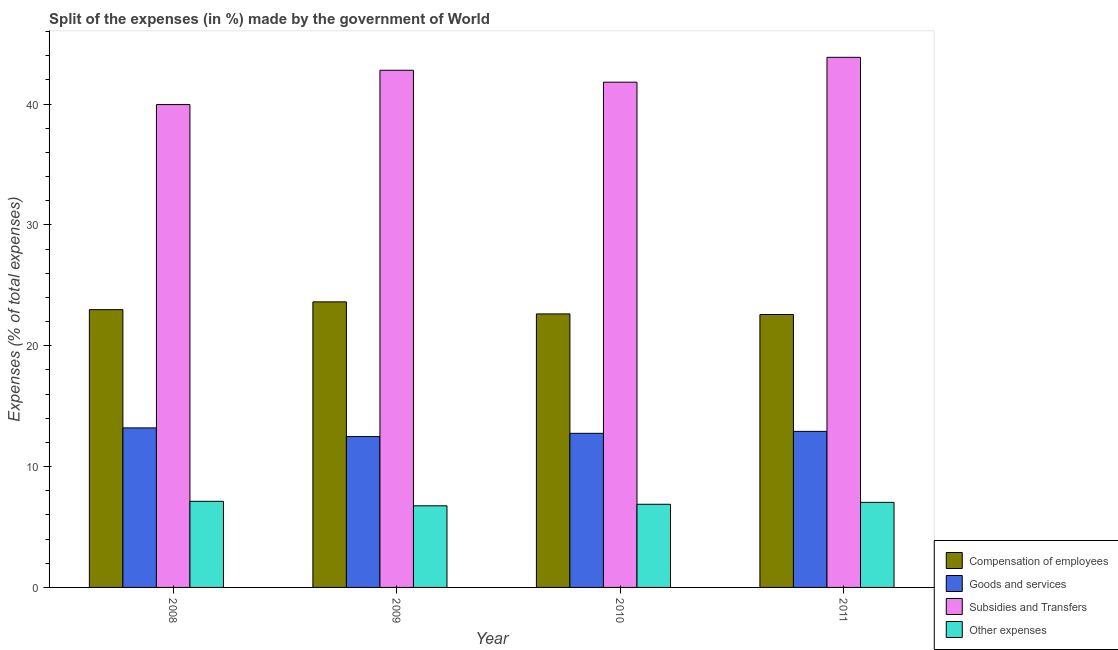How many different coloured bars are there?
Give a very brief answer. 4. Are the number of bars on each tick of the X-axis equal?
Ensure brevity in your answer.  Yes. How many bars are there on the 2nd tick from the right?
Offer a terse response. 4. In how many cases, is the number of bars for a given year not equal to the number of legend labels?
Ensure brevity in your answer.  0. What is the percentage of amount spent on compensation of employees in 2010?
Offer a very short reply. 22.63. Across all years, what is the maximum percentage of amount spent on other expenses?
Provide a succinct answer. 7.13. Across all years, what is the minimum percentage of amount spent on compensation of employees?
Ensure brevity in your answer.  22.58. What is the total percentage of amount spent on compensation of employees in the graph?
Offer a terse response. 91.83. What is the difference between the percentage of amount spent on goods and services in 2010 and that in 2011?
Ensure brevity in your answer.  -0.16. What is the difference between the percentage of amount spent on subsidies in 2008 and the percentage of amount spent on goods and services in 2010?
Ensure brevity in your answer.  -1.85. What is the average percentage of amount spent on compensation of employees per year?
Give a very brief answer. 22.96. In how many years, is the percentage of amount spent on subsidies greater than 22 %?
Your response must be concise. 4. What is the ratio of the percentage of amount spent on other expenses in 2009 to that in 2011?
Provide a short and direct response. 0.96. Is the percentage of amount spent on goods and services in 2008 less than that in 2010?
Your response must be concise. No. Is the difference between the percentage of amount spent on other expenses in 2009 and 2011 greater than the difference between the percentage of amount spent on subsidies in 2009 and 2011?
Offer a very short reply. No. What is the difference between the highest and the second highest percentage of amount spent on other expenses?
Provide a succinct answer. 0.09. What is the difference between the highest and the lowest percentage of amount spent on other expenses?
Provide a short and direct response. 0.37. Is the sum of the percentage of amount spent on subsidies in 2009 and 2011 greater than the maximum percentage of amount spent on goods and services across all years?
Provide a succinct answer. Yes. Is it the case that in every year, the sum of the percentage of amount spent on goods and services and percentage of amount spent on subsidies is greater than the sum of percentage of amount spent on other expenses and percentage of amount spent on compensation of employees?
Your response must be concise. Yes. What does the 2nd bar from the left in 2008 represents?
Provide a short and direct response. Goods and services. What does the 2nd bar from the right in 2008 represents?
Provide a succinct answer. Subsidies and Transfers. Are all the bars in the graph horizontal?
Offer a very short reply. No. How many years are there in the graph?
Your response must be concise. 4. Are the values on the major ticks of Y-axis written in scientific E-notation?
Give a very brief answer. No. Does the graph contain any zero values?
Provide a succinct answer. No. Does the graph contain grids?
Give a very brief answer. No. How many legend labels are there?
Give a very brief answer. 4. How are the legend labels stacked?
Keep it short and to the point. Vertical. What is the title of the graph?
Give a very brief answer. Split of the expenses (in %) made by the government of World. Does "Tertiary education" appear as one of the legend labels in the graph?
Your answer should be very brief. No. What is the label or title of the Y-axis?
Make the answer very short. Expenses (% of total expenses). What is the Expenses (% of total expenses) of Compensation of employees in 2008?
Offer a terse response. 22.98. What is the Expenses (% of total expenses) in Goods and services in 2008?
Your response must be concise. 13.2. What is the Expenses (% of total expenses) in Subsidies and Transfers in 2008?
Your answer should be very brief. 39.95. What is the Expenses (% of total expenses) in Other expenses in 2008?
Give a very brief answer. 7.13. What is the Expenses (% of total expenses) in Compensation of employees in 2009?
Make the answer very short. 23.63. What is the Expenses (% of total expenses) of Goods and services in 2009?
Offer a very short reply. 12.48. What is the Expenses (% of total expenses) of Subsidies and Transfers in 2009?
Make the answer very short. 42.79. What is the Expenses (% of total expenses) in Other expenses in 2009?
Keep it short and to the point. 6.75. What is the Expenses (% of total expenses) in Compensation of employees in 2010?
Offer a terse response. 22.63. What is the Expenses (% of total expenses) of Goods and services in 2010?
Provide a short and direct response. 12.75. What is the Expenses (% of total expenses) in Subsidies and Transfers in 2010?
Offer a very short reply. 41.81. What is the Expenses (% of total expenses) in Other expenses in 2010?
Your answer should be compact. 6.88. What is the Expenses (% of total expenses) of Compensation of employees in 2011?
Your answer should be very brief. 22.58. What is the Expenses (% of total expenses) of Goods and services in 2011?
Your answer should be compact. 12.91. What is the Expenses (% of total expenses) of Subsidies and Transfers in 2011?
Your response must be concise. 43.86. What is the Expenses (% of total expenses) in Other expenses in 2011?
Provide a short and direct response. 7.04. Across all years, what is the maximum Expenses (% of total expenses) in Compensation of employees?
Keep it short and to the point. 23.63. Across all years, what is the maximum Expenses (% of total expenses) in Goods and services?
Make the answer very short. 13.2. Across all years, what is the maximum Expenses (% of total expenses) in Subsidies and Transfers?
Offer a very short reply. 43.86. Across all years, what is the maximum Expenses (% of total expenses) in Other expenses?
Make the answer very short. 7.13. Across all years, what is the minimum Expenses (% of total expenses) of Compensation of employees?
Keep it short and to the point. 22.58. Across all years, what is the minimum Expenses (% of total expenses) in Goods and services?
Your answer should be compact. 12.48. Across all years, what is the minimum Expenses (% of total expenses) of Subsidies and Transfers?
Offer a terse response. 39.95. Across all years, what is the minimum Expenses (% of total expenses) in Other expenses?
Offer a terse response. 6.75. What is the total Expenses (% of total expenses) in Compensation of employees in the graph?
Make the answer very short. 91.83. What is the total Expenses (% of total expenses) in Goods and services in the graph?
Your answer should be very brief. 51.35. What is the total Expenses (% of total expenses) of Subsidies and Transfers in the graph?
Your answer should be compact. 168.41. What is the total Expenses (% of total expenses) in Other expenses in the graph?
Your answer should be very brief. 27.8. What is the difference between the Expenses (% of total expenses) in Compensation of employees in 2008 and that in 2009?
Offer a terse response. -0.64. What is the difference between the Expenses (% of total expenses) in Goods and services in 2008 and that in 2009?
Make the answer very short. 0.72. What is the difference between the Expenses (% of total expenses) of Subsidies and Transfers in 2008 and that in 2009?
Give a very brief answer. -2.84. What is the difference between the Expenses (% of total expenses) in Other expenses in 2008 and that in 2009?
Provide a short and direct response. 0.37. What is the difference between the Expenses (% of total expenses) of Compensation of employees in 2008 and that in 2010?
Make the answer very short. 0.35. What is the difference between the Expenses (% of total expenses) of Goods and services in 2008 and that in 2010?
Offer a very short reply. 0.45. What is the difference between the Expenses (% of total expenses) in Subsidies and Transfers in 2008 and that in 2010?
Your response must be concise. -1.85. What is the difference between the Expenses (% of total expenses) in Other expenses in 2008 and that in 2010?
Offer a terse response. 0.24. What is the difference between the Expenses (% of total expenses) of Compensation of employees in 2008 and that in 2011?
Give a very brief answer. 0.4. What is the difference between the Expenses (% of total expenses) of Goods and services in 2008 and that in 2011?
Your response must be concise. 0.29. What is the difference between the Expenses (% of total expenses) in Subsidies and Transfers in 2008 and that in 2011?
Ensure brevity in your answer.  -3.91. What is the difference between the Expenses (% of total expenses) of Other expenses in 2008 and that in 2011?
Ensure brevity in your answer.  0.09. What is the difference between the Expenses (% of total expenses) in Compensation of employees in 2009 and that in 2010?
Your answer should be very brief. 1. What is the difference between the Expenses (% of total expenses) of Goods and services in 2009 and that in 2010?
Offer a terse response. -0.27. What is the difference between the Expenses (% of total expenses) of Subsidies and Transfers in 2009 and that in 2010?
Ensure brevity in your answer.  0.99. What is the difference between the Expenses (% of total expenses) in Other expenses in 2009 and that in 2010?
Make the answer very short. -0.13. What is the difference between the Expenses (% of total expenses) of Compensation of employees in 2009 and that in 2011?
Keep it short and to the point. 1.04. What is the difference between the Expenses (% of total expenses) in Goods and services in 2009 and that in 2011?
Provide a short and direct response. -0.43. What is the difference between the Expenses (% of total expenses) of Subsidies and Transfers in 2009 and that in 2011?
Your answer should be compact. -1.07. What is the difference between the Expenses (% of total expenses) in Other expenses in 2009 and that in 2011?
Your answer should be compact. -0.28. What is the difference between the Expenses (% of total expenses) of Compensation of employees in 2010 and that in 2011?
Make the answer very short. 0.05. What is the difference between the Expenses (% of total expenses) of Goods and services in 2010 and that in 2011?
Provide a succinct answer. -0.16. What is the difference between the Expenses (% of total expenses) in Subsidies and Transfers in 2010 and that in 2011?
Offer a terse response. -2.06. What is the difference between the Expenses (% of total expenses) in Other expenses in 2010 and that in 2011?
Make the answer very short. -0.16. What is the difference between the Expenses (% of total expenses) in Compensation of employees in 2008 and the Expenses (% of total expenses) in Goods and services in 2009?
Your answer should be compact. 10.5. What is the difference between the Expenses (% of total expenses) in Compensation of employees in 2008 and the Expenses (% of total expenses) in Subsidies and Transfers in 2009?
Keep it short and to the point. -19.81. What is the difference between the Expenses (% of total expenses) of Compensation of employees in 2008 and the Expenses (% of total expenses) of Other expenses in 2009?
Offer a terse response. 16.23. What is the difference between the Expenses (% of total expenses) in Goods and services in 2008 and the Expenses (% of total expenses) in Subsidies and Transfers in 2009?
Give a very brief answer. -29.59. What is the difference between the Expenses (% of total expenses) in Goods and services in 2008 and the Expenses (% of total expenses) in Other expenses in 2009?
Your answer should be very brief. 6.45. What is the difference between the Expenses (% of total expenses) of Subsidies and Transfers in 2008 and the Expenses (% of total expenses) of Other expenses in 2009?
Offer a terse response. 33.2. What is the difference between the Expenses (% of total expenses) of Compensation of employees in 2008 and the Expenses (% of total expenses) of Goods and services in 2010?
Your response must be concise. 10.23. What is the difference between the Expenses (% of total expenses) in Compensation of employees in 2008 and the Expenses (% of total expenses) in Subsidies and Transfers in 2010?
Give a very brief answer. -18.82. What is the difference between the Expenses (% of total expenses) of Compensation of employees in 2008 and the Expenses (% of total expenses) of Other expenses in 2010?
Give a very brief answer. 16.1. What is the difference between the Expenses (% of total expenses) of Goods and services in 2008 and the Expenses (% of total expenses) of Subsidies and Transfers in 2010?
Make the answer very short. -28.61. What is the difference between the Expenses (% of total expenses) in Goods and services in 2008 and the Expenses (% of total expenses) in Other expenses in 2010?
Keep it short and to the point. 6.32. What is the difference between the Expenses (% of total expenses) of Subsidies and Transfers in 2008 and the Expenses (% of total expenses) of Other expenses in 2010?
Your answer should be very brief. 33.07. What is the difference between the Expenses (% of total expenses) in Compensation of employees in 2008 and the Expenses (% of total expenses) in Goods and services in 2011?
Make the answer very short. 10.07. What is the difference between the Expenses (% of total expenses) of Compensation of employees in 2008 and the Expenses (% of total expenses) of Subsidies and Transfers in 2011?
Give a very brief answer. -20.88. What is the difference between the Expenses (% of total expenses) of Compensation of employees in 2008 and the Expenses (% of total expenses) of Other expenses in 2011?
Keep it short and to the point. 15.95. What is the difference between the Expenses (% of total expenses) in Goods and services in 2008 and the Expenses (% of total expenses) in Subsidies and Transfers in 2011?
Provide a short and direct response. -30.66. What is the difference between the Expenses (% of total expenses) of Goods and services in 2008 and the Expenses (% of total expenses) of Other expenses in 2011?
Offer a very short reply. 6.16. What is the difference between the Expenses (% of total expenses) in Subsidies and Transfers in 2008 and the Expenses (% of total expenses) in Other expenses in 2011?
Provide a short and direct response. 32.92. What is the difference between the Expenses (% of total expenses) in Compensation of employees in 2009 and the Expenses (% of total expenses) in Goods and services in 2010?
Keep it short and to the point. 10.88. What is the difference between the Expenses (% of total expenses) of Compensation of employees in 2009 and the Expenses (% of total expenses) of Subsidies and Transfers in 2010?
Provide a succinct answer. -18.18. What is the difference between the Expenses (% of total expenses) of Compensation of employees in 2009 and the Expenses (% of total expenses) of Other expenses in 2010?
Offer a very short reply. 16.75. What is the difference between the Expenses (% of total expenses) in Goods and services in 2009 and the Expenses (% of total expenses) in Subsidies and Transfers in 2010?
Offer a terse response. -29.32. What is the difference between the Expenses (% of total expenses) in Goods and services in 2009 and the Expenses (% of total expenses) in Other expenses in 2010?
Provide a short and direct response. 5.6. What is the difference between the Expenses (% of total expenses) of Subsidies and Transfers in 2009 and the Expenses (% of total expenses) of Other expenses in 2010?
Provide a succinct answer. 35.91. What is the difference between the Expenses (% of total expenses) of Compensation of employees in 2009 and the Expenses (% of total expenses) of Goods and services in 2011?
Ensure brevity in your answer.  10.72. What is the difference between the Expenses (% of total expenses) in Compensation of employees in 2009 and the Expenses (% of total expenses) in Subsidies and Transfers in 2011?
Provide a short and direct response. -20.23. What is the difference between the Expenses (% of total expenses) in Compensation of employees in 2009 and the Expenses (% of total expenses) in Other expenses in 2011?
Give a very brief answer. 16.59. What is the difference between the Expenses (% of total expenses) in Goods and services in 2009 and the Expenses (% of total expenses) in Subsidies and Transfers in 2011?
Give a very brief answer. -31.38. What is the difference between the Expenses (% of total expenses) in Goods and services in 2009 and the Expenses (% of total expenses) in Other expenses in 2011?
Ensure brevity in your answer.  5.44. What is the difference between the Expenses (% of total expenses) in Subsidies and Transfers in 2009 and the Expenses (% of total expenses) in Other expenses in 2011?
Make the answer very short. 35.75. What is the difference between the Expenses (% of total expenses) in Compensation of employees in 2010 and the Expenses (% of total expenses) in Goods and services in 2011?
Keep it short and to the point. 9.72. What is the difference between the Expenses (% of total expenses) of Compensation of employees in 2010 and the Expenses (% of total expenses) of Subsidies and Transfers in 2011?
Offer a terse response. -21.23. What is the difference between the Expenses (% of total expenses) in Compensation of employees in 2010 and the Expenses (% of total expenses) in Other expenses in 2011?
Provide a succinct answer. 15.59. What is the difference between the Expenses (% of total expenses) in Goods and services in 2010 and the Expenses (% of total expenses) in Subsidies and Transfers in 2011?
Your answer should be compact. -31.11. What is the difference between the Expenses (% of total expenses) in Goods and services in 2010 and the Expenses (% of total expenses) in Other expenses in 2011?
Your answer should be very brief. 5.71. What is the difference between the Expenses (% of total expenses) of Subsidies and Transfers in 2010 and the Expenses (% of total expenses) of Other expenses in 2011?
Give a very brief answer. 34.77. What is the average Expenses (% of total expenses) in Compensation of employees per year?
Make the answer very short. 22.96. What is the average Expenses (% of total expenses) of Goods and services per year?
Give a very brief answer. 12.84. What is the average Expenses (% of total expenses) in Subsidies and Transfers per year?
Your answer should be very brief. 42.1. What is the average Expenses (% of total expenses) of Other expenses per year?
Keep it short and to the point. 6.95. In the year 2008, what is the difference between the Expenses (% of total expenses) of Compensation of employees and Expenses (% of total expenses) of Goods and services?
Your answer should be very brief. 9.78. In the year 2008, what is the difference between the Expenses (% of total expenses) of Compensation of employees and Expenses (% of total expenses) of Subsidies and Transfers?
Your response must be concise. -16.97. In the year 2008, what is the difference between the Expenses (% of total expenses) in Compensation of employees and Expenses (% of total expenses) in Other expenses?
Your answer should be compact. 15.86. In the year 2008, what is the difference between the Expenses (% of total expenses) of Goods and services and Expenses (% of total expenses) of Subsidies and Transfers?
Offer a very short reply. -26.75. In the year 2008, what is the difference between the Expenses (% of total expenses) in Goods and services and Expenses (% of total expenses) in Other expenses?
Provide a succinct answer. 6.07. In the year 2008, what is the difference between the Expenses (% of total expenses) in Subsidies and Transfers and Expenses (% of total expenses) in Other expenses?
Keep it short and to the point. 32.83. In the year 2009, what is the difference between the Expenses (% of total expenses) of Compensation of employees and Expenses (% of total expenses) of Goods and services?
Make the answer very short. 11.15. In the year 2009, what is the difference between the Expenses (% of total expenses) of Compensation of employees and Expenses (% of total expenses) of Subsidies and Transfers?
Provide a short and direct response. -19.16. In the year 2009, what is the difference between the Expenses (% of total expenses) in Compensation of employees and Expenses (% of total expenses) in Other expenses?
Offer a terse response. 16.87. In the year 2009, what is the difference between the Expenses (% of total expenses) of Goods and services and Expenses (% of total expenses) of Subsidies and Transfers?
Give a very brief answer. -30.31. In the year 2009, what is the difference between the Expenses (% of total expenses) of Goods and services and Expenses (% of total expenses) of Other expenses?
Your response must be concise. 5.73. In the year 2009, what is the difference between the Expenses (% of total expenses) in Subsidies and Transfers and Expenses (% of total expenses) in Other expenses?
Offer a terse response. 36.04. In the year 2010, what is the difference between the Expenses (% of total expenses) in Compensation of employees and Expenses (% of total expenses) in Goods and services?
Provide a short and direct response. 9.88. In the year 2010, what is the difference between the Expenses (% of total expenses) in Compensation of employees and Expenses (% of total expenses) in Subsidies and Transfers?
Make the answer very short. -19.18. In the year 2010, what is the difference between the Expenses (% of total expenses) of Compensation of employees and Expenses (% of total expenses) of Other expenses?
Make the answer very short. 15.75. In the year 2010, what is the difference between the Expenses (% of total expenses) in Goods and services and Expenses (% of total expenses) in Subsidies and Transfers?
Ensure brevity in your answer.  -29.05. In the year 2010, what is the difference between the Expenses (% of total expenses) of Goods and services and Expenses (% of total expenses) of Other expenses?
Make the answer very short. 5.87. In the year 2010, what is the difference between the Expenses (% of total expenses) of Subsidies and Transfers and Expenses (% of total expenses) of Other expenses?
Provide a short and direct response. 34.93. In the year 2011, what is the difference between the Expenses (% of total expenses) of Compensation of employees and Expenses (% of total expenses) of Goods and services?
Ensure brevity in your answer.  9.67. In the year 2011, what is the difference between the Expenses (% of total expenses) in Compensation of employees and Expenses (% of total expenses) in Subsidies and Transfers?
Offer a terse response. -21.28. In the year 2011, what is the difference between the Expenses (% of total expenses) in Compensation of employees and Expenses (% of total expenses) in Other expenses?
Provide a succinct answer. 15.55. In the year 2011, what is the difference between the Expenses (% of total expenses) in Goods and services and Expenses (% of total expenses) in Subsidies and Transfers?
Your answer should be very brief. -30.95. In the year 2011, what is the difference between the Expenses (% of total expenses) of Goods and services and Expenses (% of total expenses) of Other expenses?
Give a very brief answer. 5.87. In the year 2011, what is the difference between the Expenses (% of total expenses) in Subsidies and Transfers and Expenses (% of total expenses) in Other expenses?
Provide a short and direct response. 36.82. What is the ratio of the Expenses (% of total expenses) of Compensation of employees in 2008 to that in 2009?
Offer a terse response. 0.97. What is the ratio of the Expenses (% of total expenses) of Goods and services in 2008 to that in 2009?
Your response must be concise. 1.06. What is the ratio of the Expenses (% of total expenses) of Subsidies and Transfers in 2008 to that in 2009?
Give a very brief answer. 0.93. What is the ratio of the Expenses (% of total expenses) of Other expenses in 2008 to that in 2009?
Your answer should be very brief. 1.05. What is the ratio of the Expenses (% of total expenses) in Compensation of employees in 2008 to that in 2010?
Provide a succinct answer. 1.02. What is the ratio of the Expenses (% of total expenses) in Goods and services in 2008 to that in 2010?
Keep it short and to the point. 1.04. What is the ratio of the Expenses (% of total expenses) of Subsidies and Transfers in 2008 to that in 2010?
Your answer should be very brief. 0.96. What is the ratio of the Expenses (% of total expenses) in Other expenses in 2008 to that in 2010?
Your answer should be very brief. 1.04. What is the ratio of the Expenses (% of total expenses) in Compensation of employees in 2008 to that in 2011?
Ensure brevity in your answer.  1.02. What is the ratio of the Expenses (% of total expenses) of Goods and services in 2008 to that in 2011?
Your response must be concise. 1.02. What is the ratio of the Expenses (% of total expenses) of Subsidies and Transfers in 2008 to that in 2011?
Keep it short and to the point. 0.91. What is the ratio of the Expenses (% of total expenses) of Other expenses in 2008 to that in 2011?
Offer a very short reply. 1.01. What is the ratio of the Expenses (% of total expenses) of Compensation of employees in 2009 to that in 2010?
Make the answer very short. 1.04. What is the ratio of the Expenses (% of total expenses) in Goods and services in 2009 to that in 2010?
Provide a short and direct response. 0.98. What is the ratio of the Expenses (% of total expenses) in Subsidies and Transfers in 2009 to that in 2010?
Offer a very short reply. 1.02. What is the ratio of the Expenses (% of total expenses) of Other expenses in 2009 to that in 2010?
Keep it short and to the point. 0.98. What is the ratio of the Expenses (% of total expenses) in Compensation of employees in 2009 to that in 2011?
Give a very brief answer. 1.05. What is the ratio of the Expenses (% of total expenses) in Goods and services in 2009 to that in 2011?
Offer a very short reply. 0.97. What is the ratio of the Expenses (% of total expenses) of Subsidies and Transfers in 2009 to that in 2011?
Keep it short and to the point. 0.98. What is the ratio of the Expenses (% of total expenses) in Other expenses in 2009 to that in 2011?
Provide a short and direct response. 0.96. What is the ratio of the Expenses (% of total expenses) in Goods and services in 2010 to that in 2011?
Your response must be concise. 0.99. What is the ratio of the Expenses (% of total expenses) in Subsidies and Transfers in 2010 to that in 2011?
Your response must be concise. 0.95. What is the ratio of the Expenses (% of total expenses) of Other expenses in 2010 to that in 2011?
Provide a short and direct response. 0.98. What is the difference between the highest and the second highest Expenses (% of total expenses) of Compensation of employees?
Your response must be concise. 0.64. What is the difference between the highest and the second highest Expenses (% of total expenses) of Goods and services?
Offer a very short reply. 0.29. What is the difference between the highest and the second highest Expenses (% of total expenses) of Subsidies and Transfers?
Your answer should be very brief. 1.07. What is the difference between the highest and the second highest Expenses (% of total expenses) in Other expenses?
Give a very brief answer. 0.09. What is the difference between the highest and the lowest Expenses (% of total expenses) in Compensation of employees?
Offer a terse response. 1.04. What is the difference between the highest and the lowest Expenses (% of total expenses) of Goods and services?
Your answer should be compact. 0.72. What is the difference between the highest and the lowest Expenses (% of total expenses) in Subsidies and Transfers?
Offer a very short reply. 3.91. What is the difference between the highest and the lowest Expenses (% of total expenses) of Other expenses?
Provide a short and direct response. 0.37. 